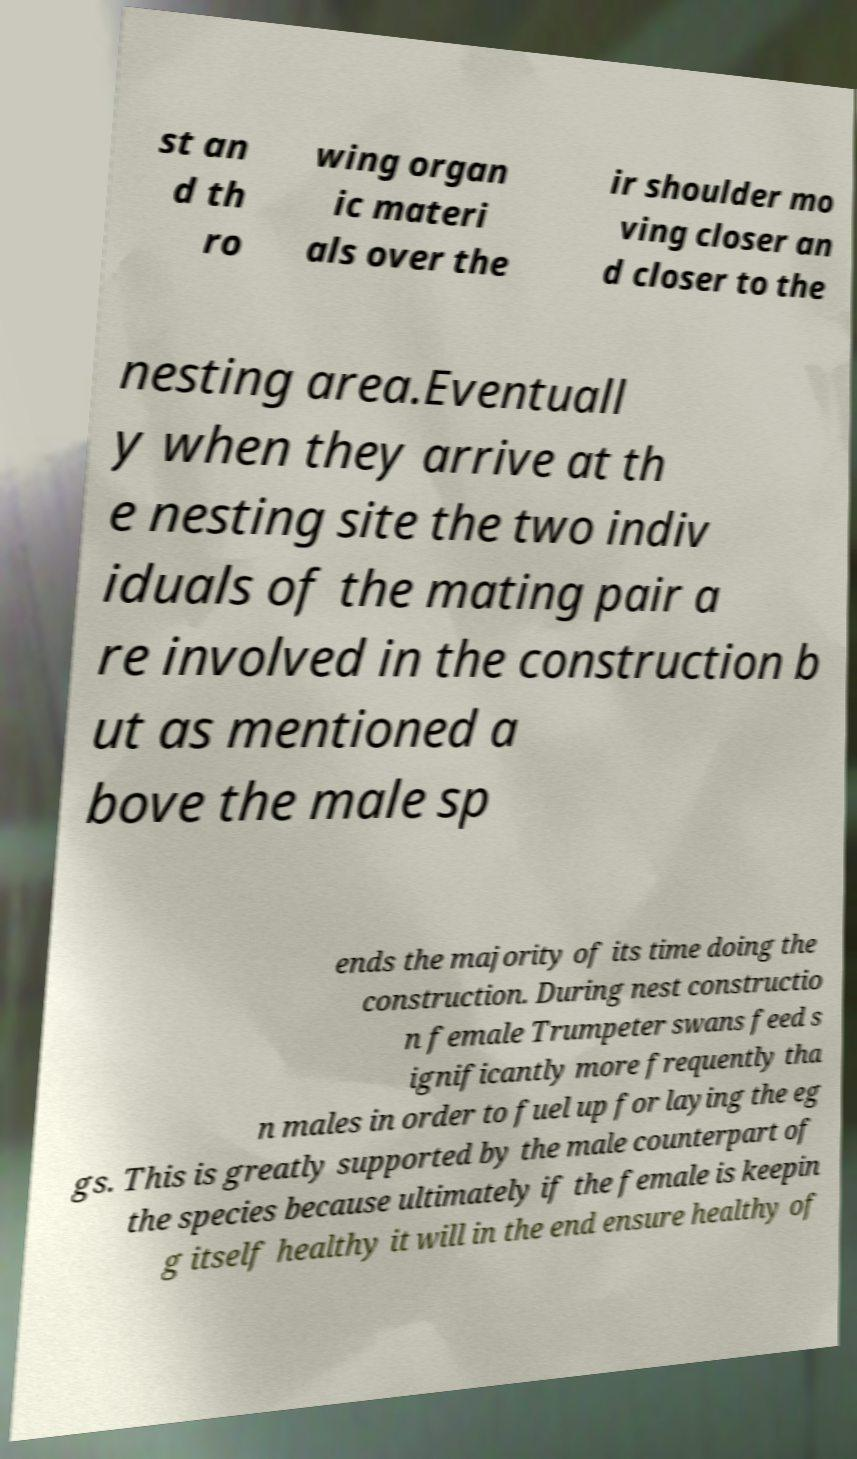Could you extract and type out the text from this image? st an d th ro wing organ ic materi als over the ir shoulder mo ving closer an d closer to the nesting area.Eventuall y when they arrive at th e nesting site the two indiv iduals of the mating pair a re involved in the construction b ut as mentioned a bove the male sp ends the majority of its time doing the construction. During nest constructio n female Trumpeter swans feed s ignificantly more frequently tha n males in order to fuel up for laying the eg gs. This is greatly supported by the male counterpart of the species because ultimately if the female is keepin g itself healthy it will in the end ensure healthy of 